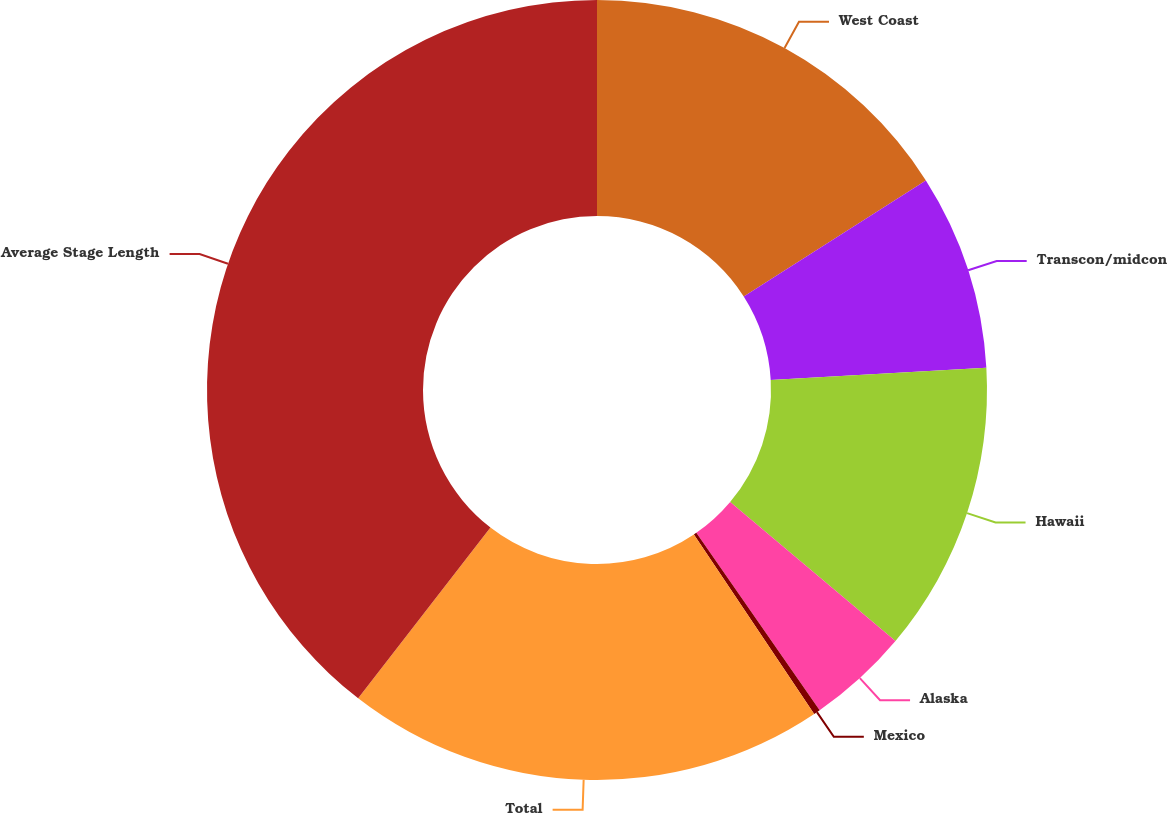Convert chart. <chart><loc_0><loc_0><loc_500><loc_500><pie_chart><fcel>West Coast<fcel>Transcon/midcon<fcel>Hawaii<fcel>Alaska<fcel>Mexico<fcel>Total<fcel>Average Stage Length<nl><fcel>15.97%<fcel>8.12%<fcel>12.04%<fcel>4.2%<fcel>0.27%<fcel>19.89%<fcel>39.51%<nl></chart> 